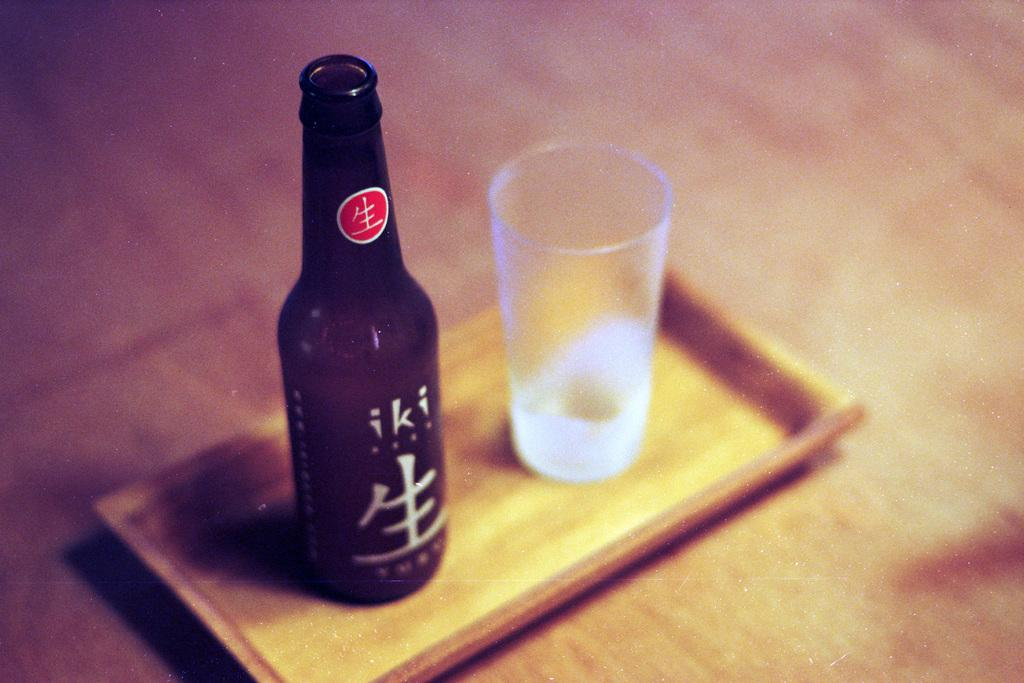What type of beverage container is present in the image? There is a wine bottle in the image. What is used for drinking the wine in the image? There is a glass in the image. How are the wine bottle and glass arranged in the image? Both the wine bottle and glass are kept in a tray. What type of architectural structure can be seen in the image? There is no architectural structure present in the image; it only features a wine bottle, glass, and tray. 